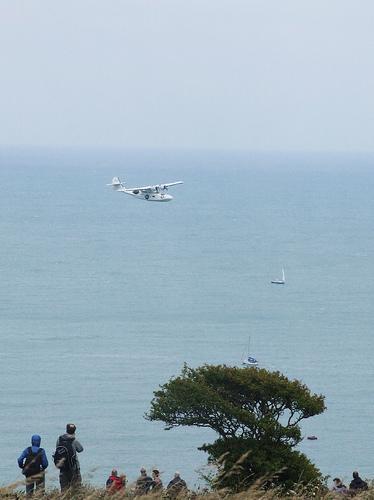How many planes are flying?
Give a very brief answer. 1. How many boats are on the water?
Give a very brief answer. 2. 